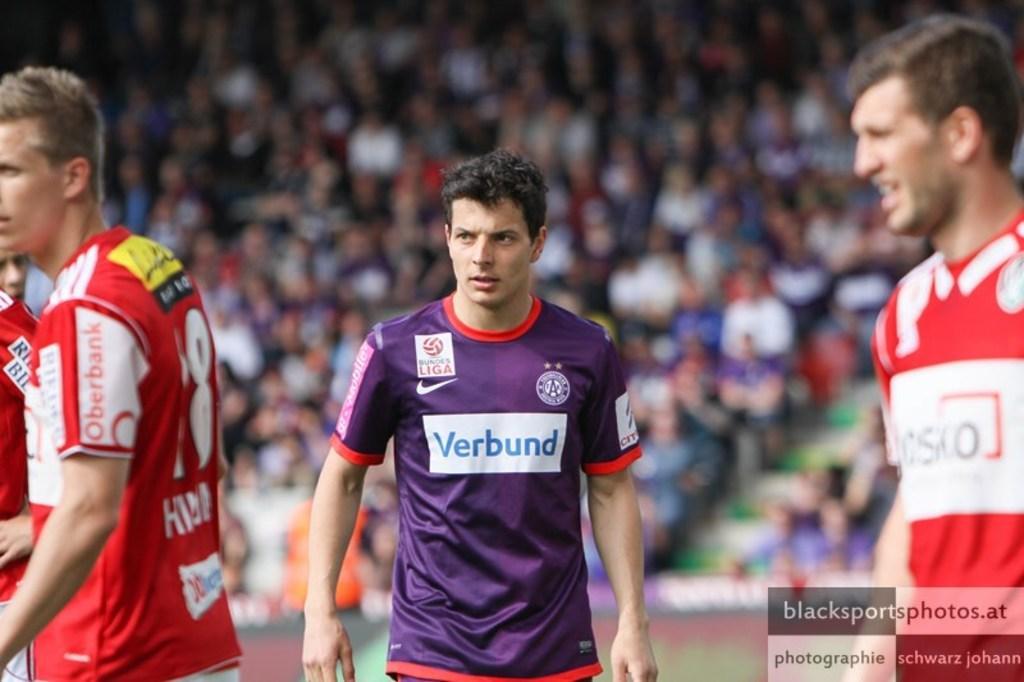Describe this image in one or two sentences. In this picture there is a man who is wearing purple color t-shirt. Beside him I can see other players who are wearing the same t-shirt. In the background I can see the audience on the stadium. In the bottom right corner there is a watermark. 